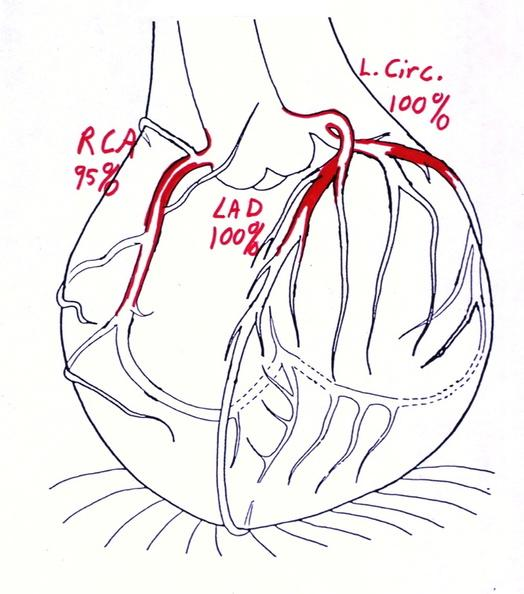s carcinomatosis endometrium primary present?
Answer the question using a single word or phrase. No 